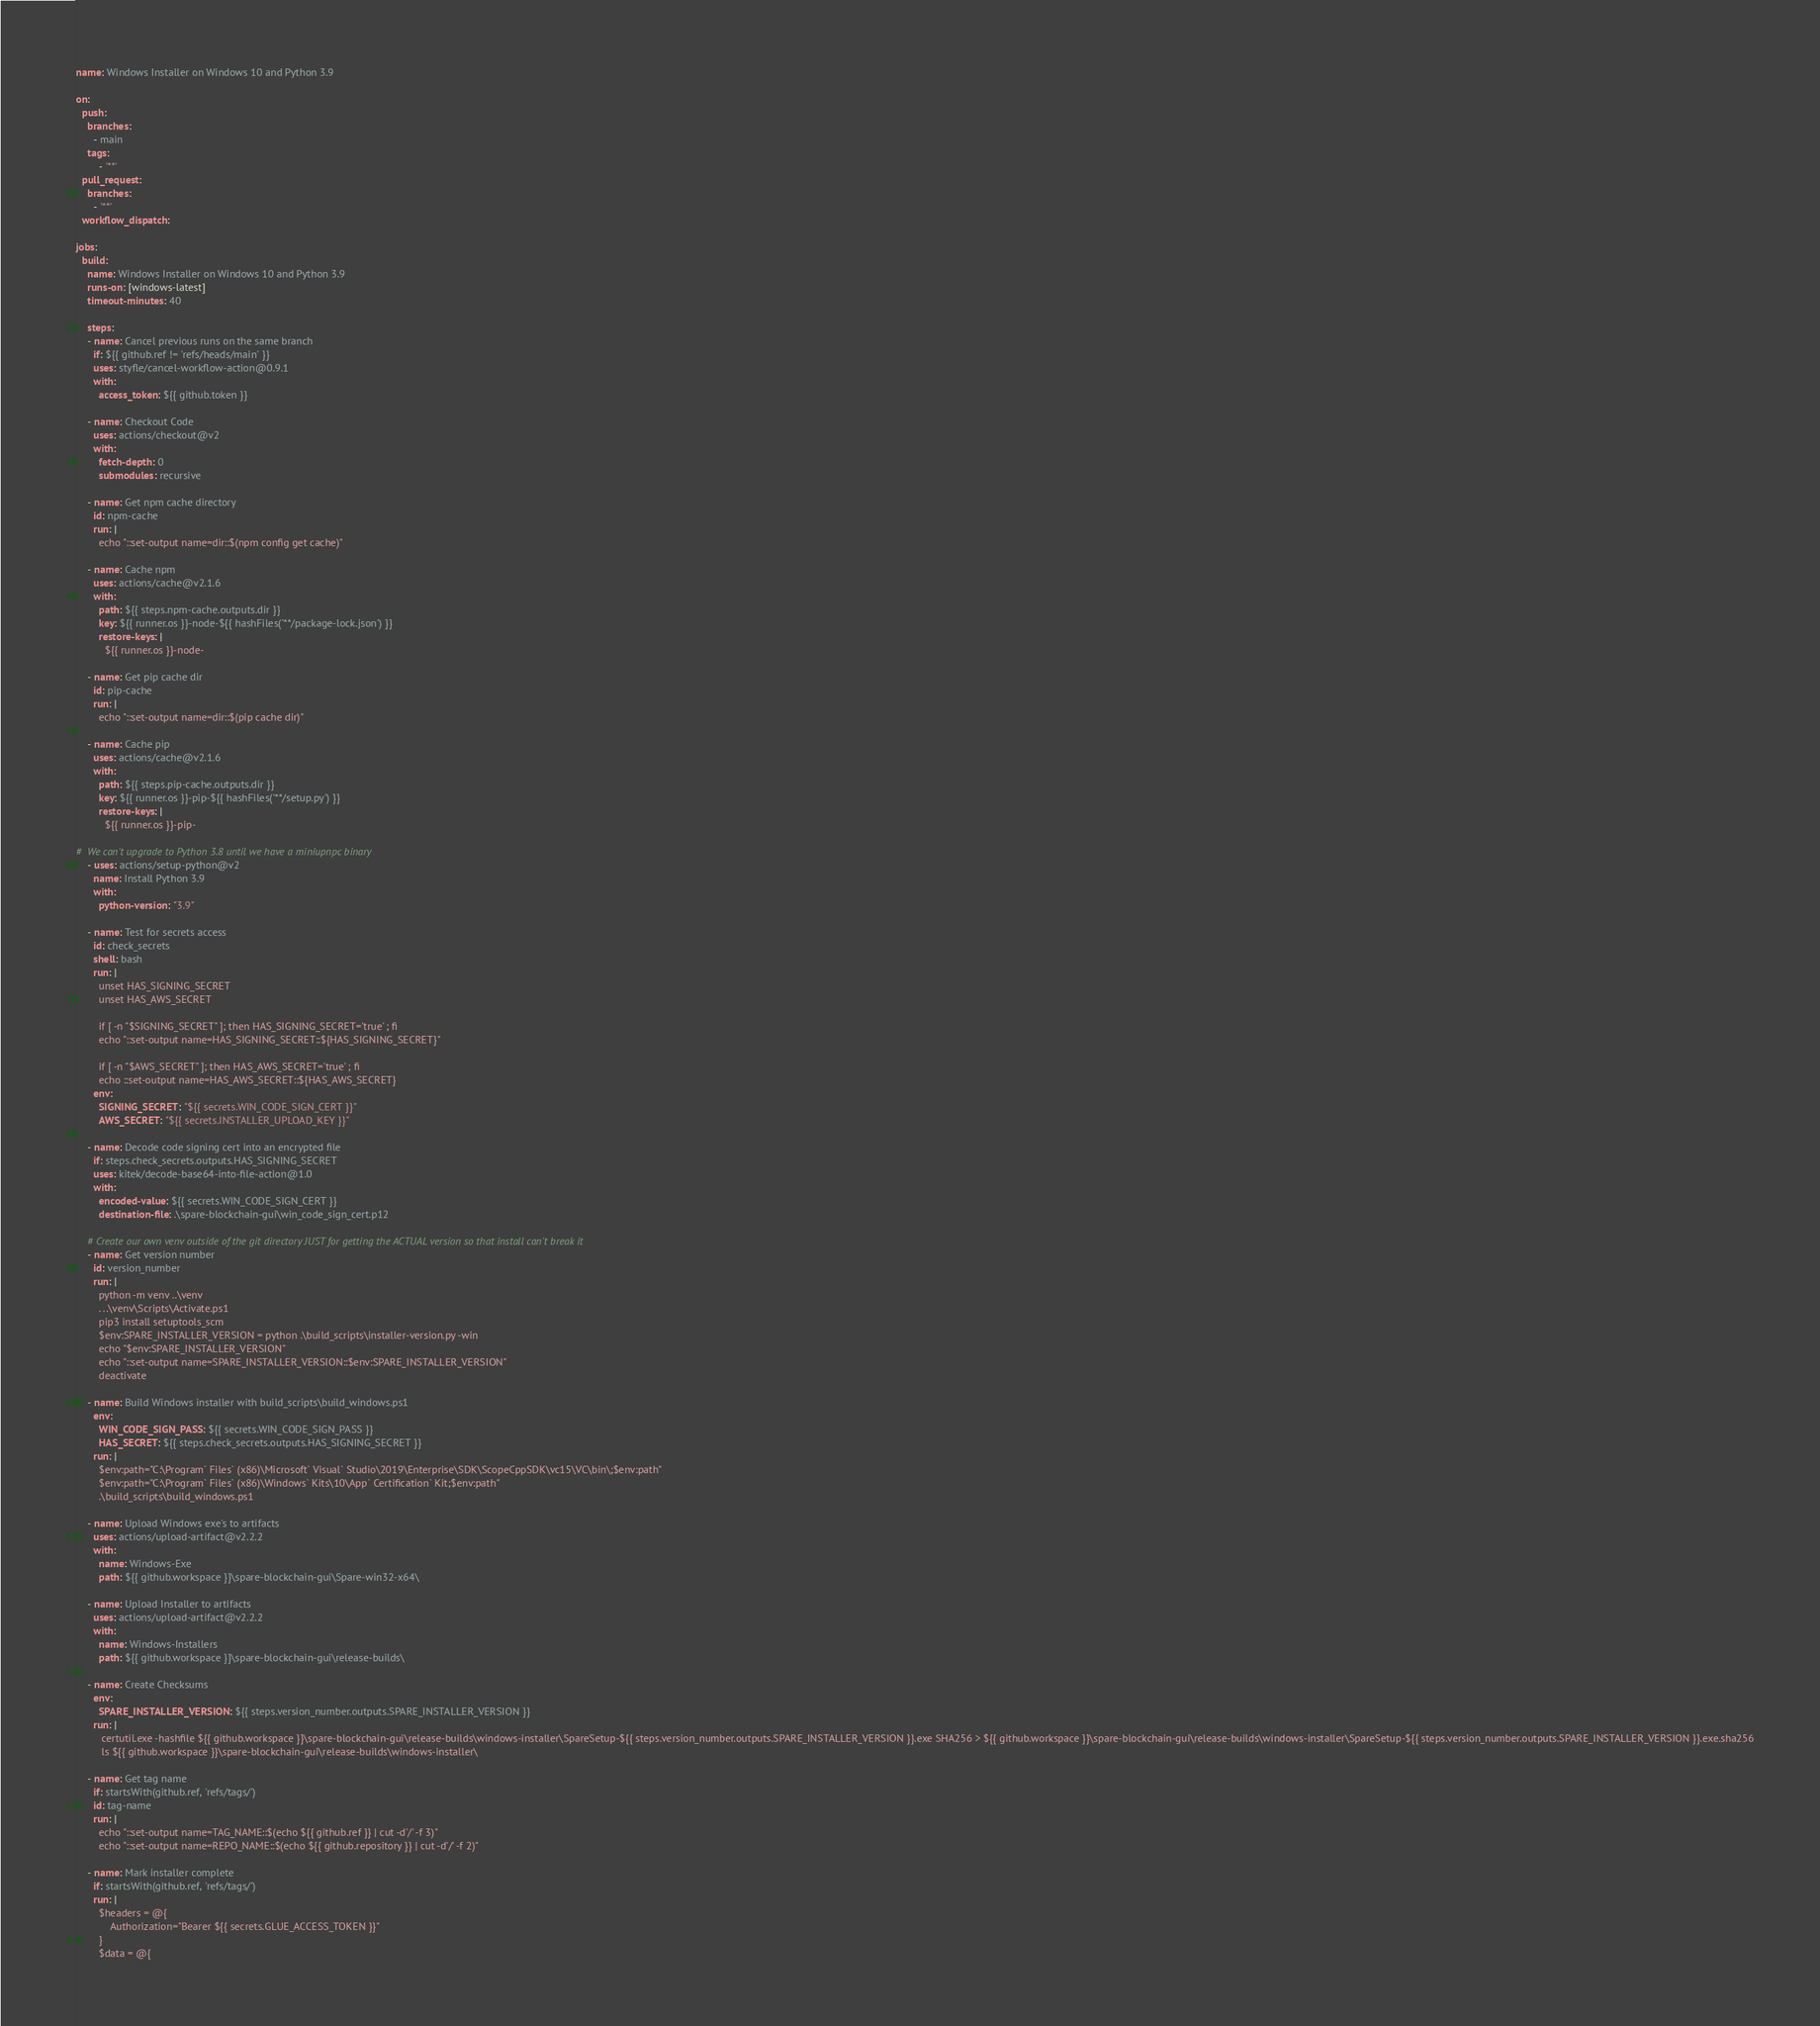<code> <loc_0><loc_0><loc_500><loc_500><_YAML_>name: Windows Installer on Windows 10 and Python 3.9

on:
  push:
    branches:
      - main
    tags:
        - '**'
  pull_request:
    branches:
      - '**'
  workflow_dispatch:

jobs:
  build:
    name: Windows Installer on Windows 10 and Python 3.9
    runs-on: [windows-latest]
    timeout-minutes: 40

    steps:
    - name: Cancel previous runs on the same branch
      if: ${{ github.ref != 'refs/heads/main' }}
      uses: styfle/cancel-workflow-action@0.9.1
      with:
        access_token: ${{ github.token }}

    - name: Checkout Code
      uses: actions/checkout@v2
      with:
        fetch-depth: 0
        submodules: recursive

    - name: Get npm cache directory
      id: npm-cache
      run: |
        echo "::set-output name=dir::$(npm config get cache)"

    - name: Cache npm
      uses: actions/cache@v2.1.6
      with:
        path: ${{ steps.npm-cache.outputs.dir }}
        key: ${{ runner.os }}-node-${{ hashFiles('**/package-lock.json') }}
        restore-keys: |
          ${{ runner.os }}-node-

    - name: Get pip cache dir
      id: pip-cache
      run: |
        echo "::set-output name=dir::$(pip cache dir)"

    - name: Cache pip
      uses: actions/cache@v2.1.6
      with:
        path: ${{ steps.pip-cache.outputs.dir }}
        key: ${{ runner.os }}-pip-${{ hashFiles('**/setup.py') }}
        restore-keys: |
          ${{ runner.os }}-pip-

#  We can't upgrade to Python 3.8 until we have a miniupnpc binary
    - uses: actions/setup-python@v2
      name: Install Python 3.9
      with:
        python-version: "3.9"

    - name: Test for secrets access
      id: check_secrets
      shell: bash
      run: |
        unset HAS_SIGNING_SECRET
        unset HAS_AWS_SECRET

        if [ -n "$SIGNING_SECRET" ]; then HAS_SIGNING_SECRET='true' ; fi
        echo "::set-output name=HAS_SIGNING_SECRET::${HAS_SIGNING_SECRET}"

        if [ -n "$AWS_SECRET" ]; then HAS_AWS_SECRET='true' ; fi
        echo ::set-output name=HAS_AWS_SECRET::${HAS_AWS_SECRET}
      env:
        SIGNING_SECRET: "${{ secrets.WIN_CODE_SIGN_CERT }}"
        AWS_SECRET: "${{ secrets.INSTALLER_UPLOAD_KEY }}"

    - name: Decode code signing cert into an encrypted file
      if: steps.check_secrets.outputs.HAS_SIGNING_SECRET
      uses: kitek/decode-base64-into-file-action@1.0
      with:
        encoded-value: ${{ secrets.WIN_CODE_SIGN_CERT }}
        destination-file: .\spare-blockchain-gui\win_code_sign_cert.p12

    # Create our own venv outside of the git directory JUST for getting the ACTUAL version so that install can't break it
    - name: Get version number
      id: version_number
      run: |
        python -m venv ..\venv
        . ..\venv\Scripts\Activate.ps1
        pip3 install setuptools_scm
        $env:SPARE_INSTALLER_VERSION = python .\build_scripts\installer-version.py -win
        echo "$env:SPARE_INSTALLER_VERSION"
        echo "::set-output name=SPARE_INSTALLER_VERSION::$env:SPARE_INSTALLER_VERSION"
        deactivate

    - name: Build Windows installer with build_scripts\build_windows.ps1
      env:
        WIN_CODE_SIGN_PASS: ${{ secrets.WIN_CODE_SIGN_PASS }}
        HAS_SECRET: ${{ steps.check_secrets.outputs.HAS_SIGNING_SECRET }}
      run: |
        $env:path="C:\Program` Files` (x86)\Microsoft` Visual` Studio\2019\Enterprise\SDK\ScopeCppSDK\vc15\VC\bin\;$env:path"
        $env:path="C:\Program` Files` (x86)\Windows` Kits\10\App` Certification` Kit;$env:path"
        .\build_scripts\build_windows.ps1

    - name: Upload Windows exe's to artifacts
      uses: actions/upload-artifact@v2.2.2
      with:
        name: Windows-Exe
        path: ${{ github.workspace }}\spare-blockchain-gui\Spare-win32-x64\

    - name: Upload Installer to artifacts
      uses: actions/upload-artifact@v2.2.2
      with:
        name: Windows-Installers
        path: ${{ github.workspace }}\spare-blockchain-gui\release-builds\

    - name: Create Checksums
      env:
        SPARE_INSTALLER_VERSION: ${{ steps.version_number.outputs.SPARE_INSTALLER_VERSION }}
      run: |
         certutil.exe -hashfile ${{ github.workspace }}\spare-blockchain-gui\release-builds\windows-installer\SpareSetup-${{ steps.version_number.outputs.SPARE_INSTALLER_VERSION }}.exe SHA256 > ${{ github.workspace }}\spare-blockchain-gui\release-builds\windows-installer\SpareSetup-${{ steps.version_number.outputs.SPARE_INSTALLER_VERSION }}.exe.sha256
         ls ${{ github.workspace }}\spare-blockchain-gui\release-builds\windows-installer\

    - name: Get tag name
      if: startsWith(github.ref, 'refs/tags/')
      id: tag-name
      run: |
        echo "::set-output name=TAG_NAME::$(echo ${{ github.ref }} | cut -d'/' -f 3)"
        echo "::set-output name=REPO_NAME::$(echo ${{ github.repository }} | cut -d'/' -f 2)"

    - name: Mark installer complete
      if: startsWith(github.ref, 'refs/tags/')
      run: |
        $headers = @{
            Authorization="Bearer ${{ secrets.GLUE_ACCESS_TOKEN }}"
        }
        $data = @{</code> 